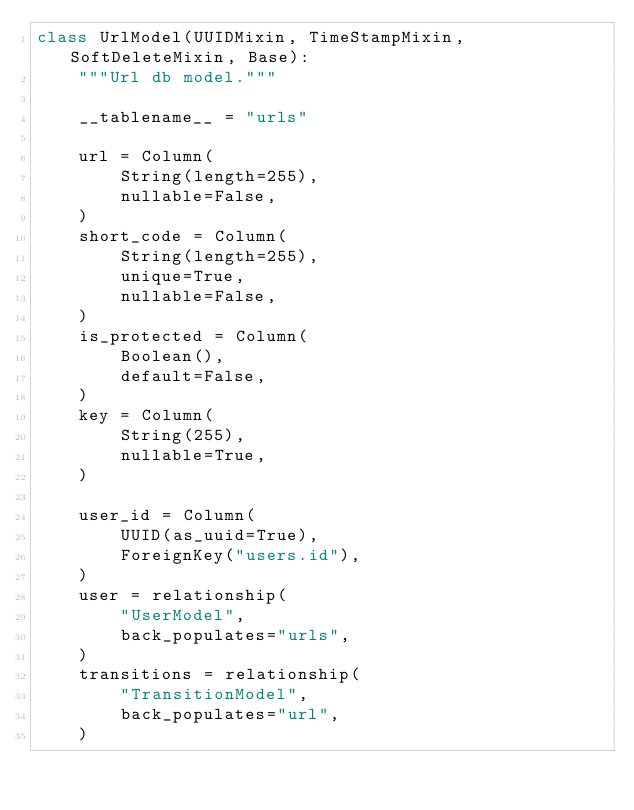<code> <loc_0><loc_0><loc_500><loc_500><_Python_>class UrlModel(UUIDMixin, TimeStampMixin, SoftDeleteMixin, Base):
    """Url db model."""

    __tablename__ = "urls"

    url = Column(
        String(length=255),
        nullable=False,
    )
    short_code = Column(
        String(length=255),
        unique=True,
        nullable=False,
    )
    is_protected = Column(
        Boolean(),
        default=False,
    )
    key = Column(
        String(255),
        nullable=True,
    )

    user_id = Column(
        UUID(as_uuid=True),
        ForeignKey("users.id"),
    )
    user = relationship(
        "UserModel",
        back_populates="urls",
    )
    transitions = relationship(
        "TransitionModel",
        back_populates="url",
    )
</code> 